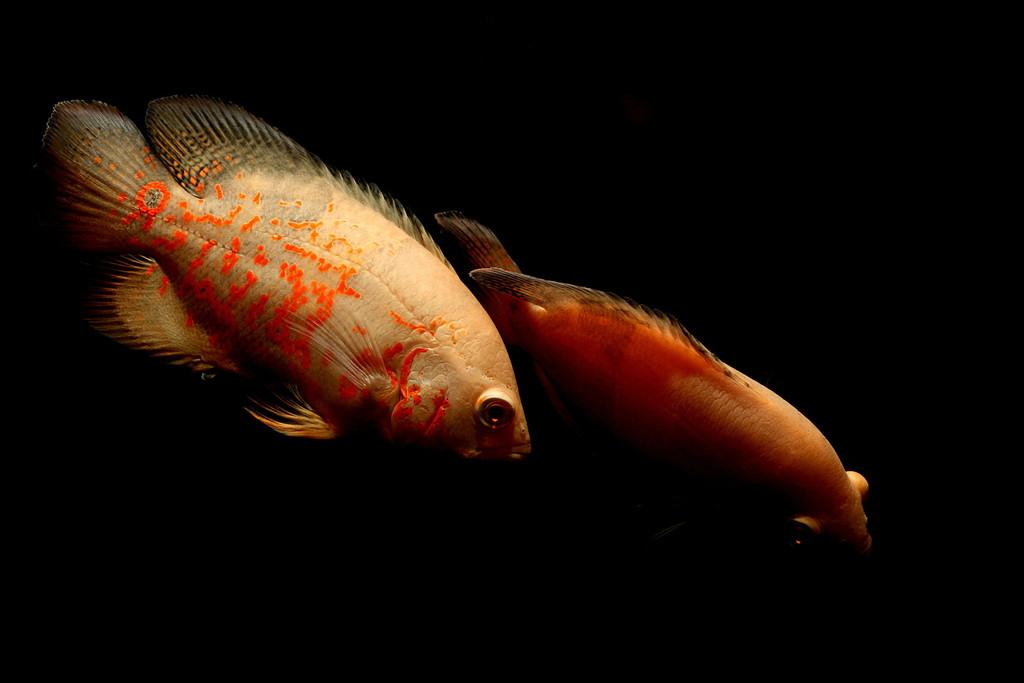How many fishes can be seen in the image? There are two fishes present in the image. What type of club can be seen in the image? There is no club present in the image; it features two fishes. How many clocks are visible in the image? There are no clocks present in the image; it features two fishes. 